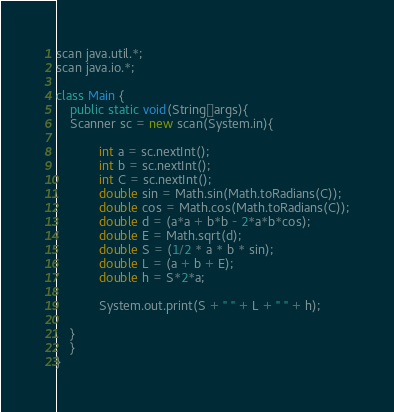<code> <loc_0><loc_0><loc_500><loc_500><_Java_>scan java.util.*;
scan java.io.*;

class Main {
    public static void(String[]args){
    Scanner sc = new scan(System.in){
    
            int a = sc.nextInt();
            int b = sc.nextInt();
            int C = sc.nextInt();
            double sin = Math.sin(Math.toRadians(C));
            double cos = Math.cos(Math.toRadians(C));
            double d = (a*a + b*b - 2*a*b*cos); 
            double E = Math.sqrt(d);
            double S = (1/2 * a * b * sin);
            double L = (a + b + E);
            double h = S*2*a;

            System.out.print(S + " " + L + " " + h);

    }
    }
}</code> 